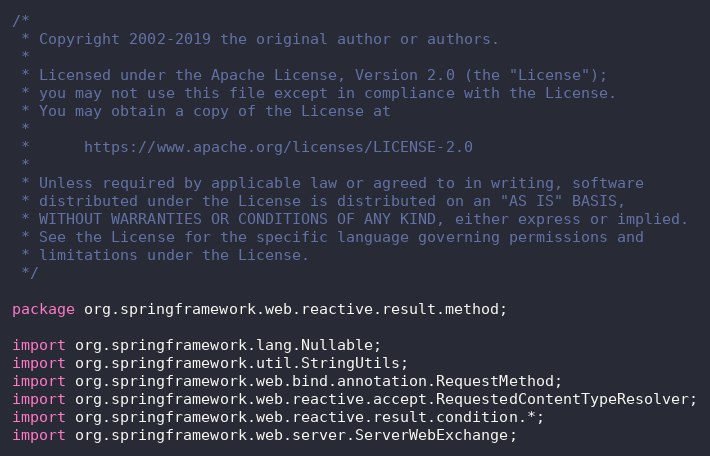Convert code to text. <code><loc_0><loc_0><loc_500><loc_500><_Java_>/*
 * Copyright 2002-2019 the original author or authors.
 *
 * Licensed under the Apache License, Version 2.0 (the "License");
 * you may not use this file except in compliance with the License.
 * You may obtain a copy of the License at
 *
 *      https://www.apache.org/licenses/LICENSE-2.0
 *
 * Unless required by applicable law or agreed to in writing, software
 * distributed under the License is distributed on an "AS IS" BASIS,
 * WITHOUT WARRANTIES OR CONDITIONS OF ANY KIND, either express or implied.
 * See the License for the specific language governing permissions and
 * limitations under the License.
 */

package org.springframework.web.reactive.result.method;

import org.springframework.lang.Nullable;
import org.springframework.util.StringUtils;
import org.springframework.web.bind.annotation.RequestMethod;
import org.springframework.web.reactive.accept.RequestedContentTypeResolver;
import org.springframework.web.reactive.result.condition.*;
import org.springframework.web.server.ServerWebExchange;</code> 